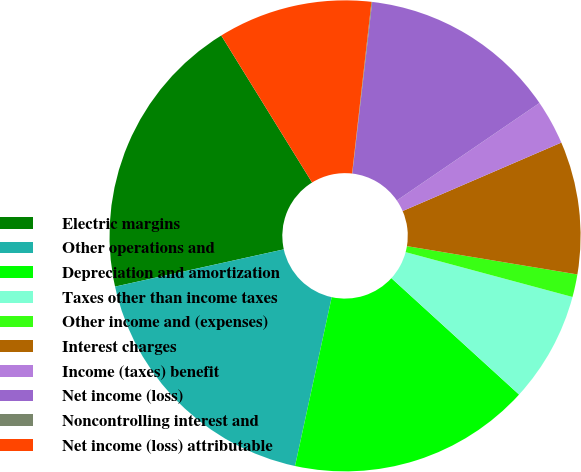Convert chart. <chart><loc_0><loc_0><loc_500><loc_500><pie_chart><fcel>Electric margins<fcel>Other operations and<fcel>Depreciation and amortization<fcel>Taxes other than income taxes<fcel>Other income and (expenses)<fcel>Interest charges<fcel>Income (taxes) benefit<fcel>Net income (loss)<fcel>Noncontrolling interest and<fcel>Net income (loss) attributable<nl><fcel>19.65%<fcel>18.14%<fcel>16.64%<fcel>7.59%<fcel>1.56%<fcel>9.1%<fcel>3.06%<fcel>13.62%<fcel>0.05%<fcel>10.6%<nl></chart> 